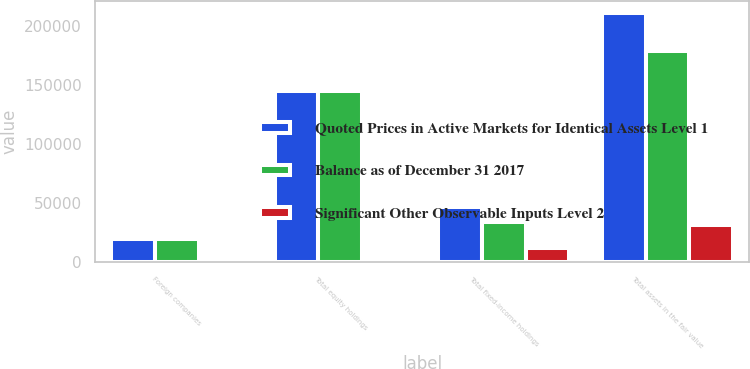Convert chart to OTSL. <chart><loc_0><loc_0><loc_500><loc_500><stacked_bar_chart><ecel><fcel>Foreign companies<fcel>Total equity holdings<fcel>Total fixed-income holdings<fcel>Total assets in the fair value<nl><fcel>Quoted Prices in Active Markets for Identical Assets Level 1<fcel>19498<fcel>144795<fcel>46675<fcel>210787<nl><fcel>Balance as of December 31 2017<fcel>19495<fcel>144792<fcel>34264<fcel>179056<nl><fcel>Significant Other Observable Inputs Level 2<fcel>3<fcel>3<fcel>12411<fcel>31731<nl></chart> 